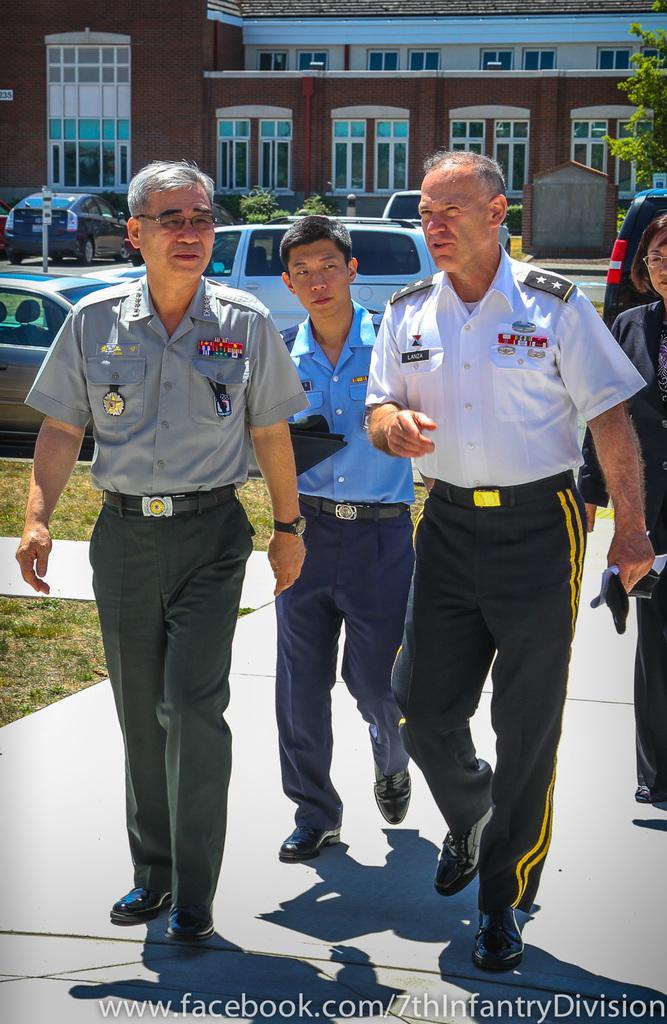In one or two sentences, can you explain what this image depicts? In this image there are three persons who are walking and they are talking something, in the background there is a building trees and some vehicles. At the bottom there is grass and a walkway. 